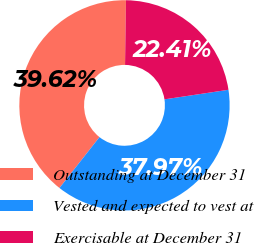<chart> <loc_0><loc_0><loc_500><loc_500><pie_chart><fcel>Outstanding at December 31<fcel>Vested and expected to vest at<fcel>Exercisable at December 31<nl><fcel>39.62%<fcel>37.97%<fcel>22.41%<nl></chart> 